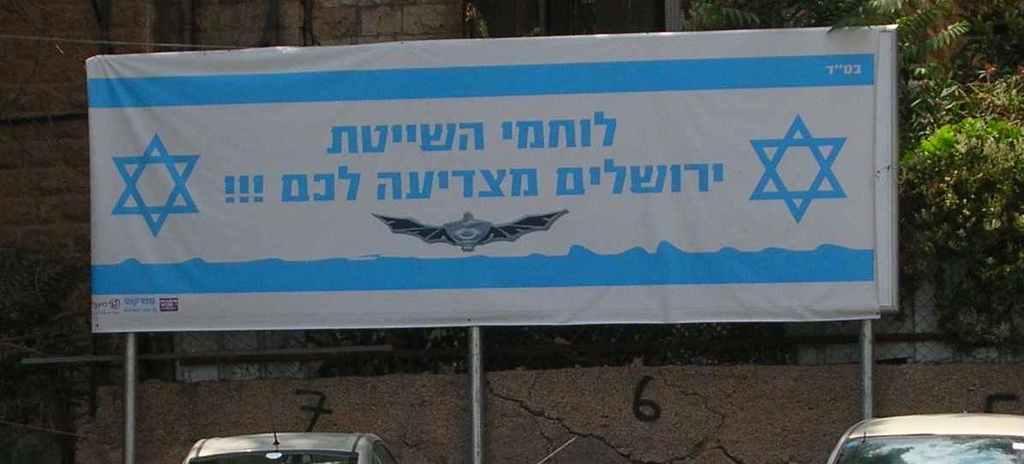How would you summarize this image in a sentence or two? In this image we can see some written text on the board, there are two vehicles, metal fence, wall, trees. 